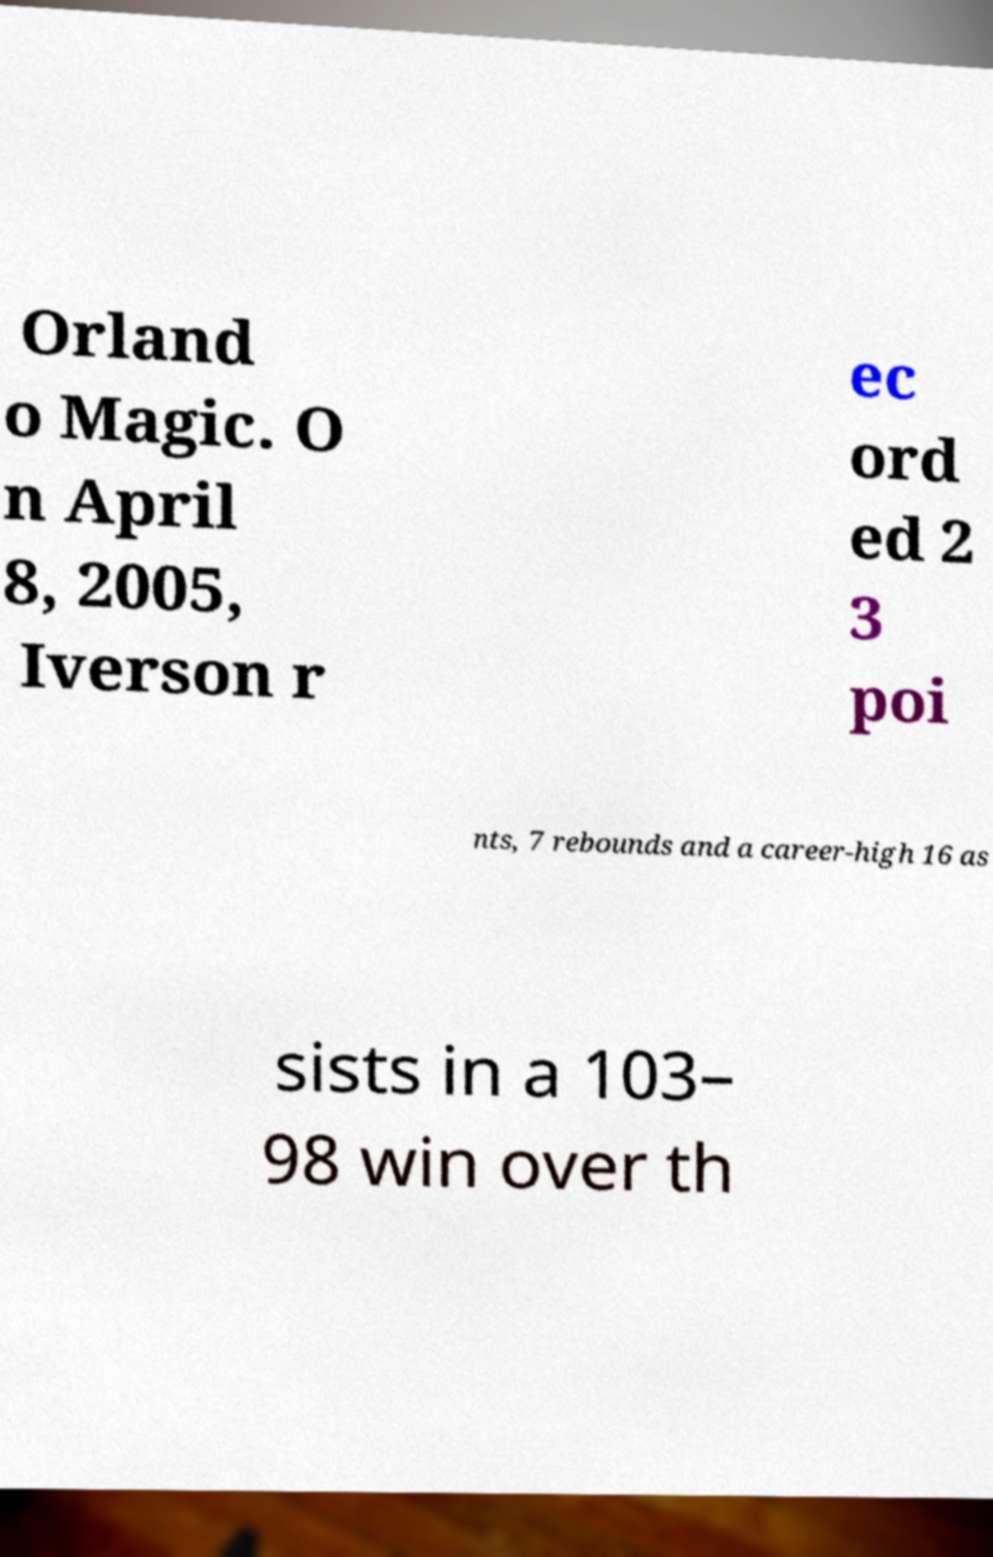For documentation purposes, I need the text within this image transcribed. Could you provide that? Orland o Magic. O n April 8, 2005, Iverson r ec ord ed 2 3 poi nts, 7 rebounds and a career-high 16 as sists in a 103– 98 win over th 